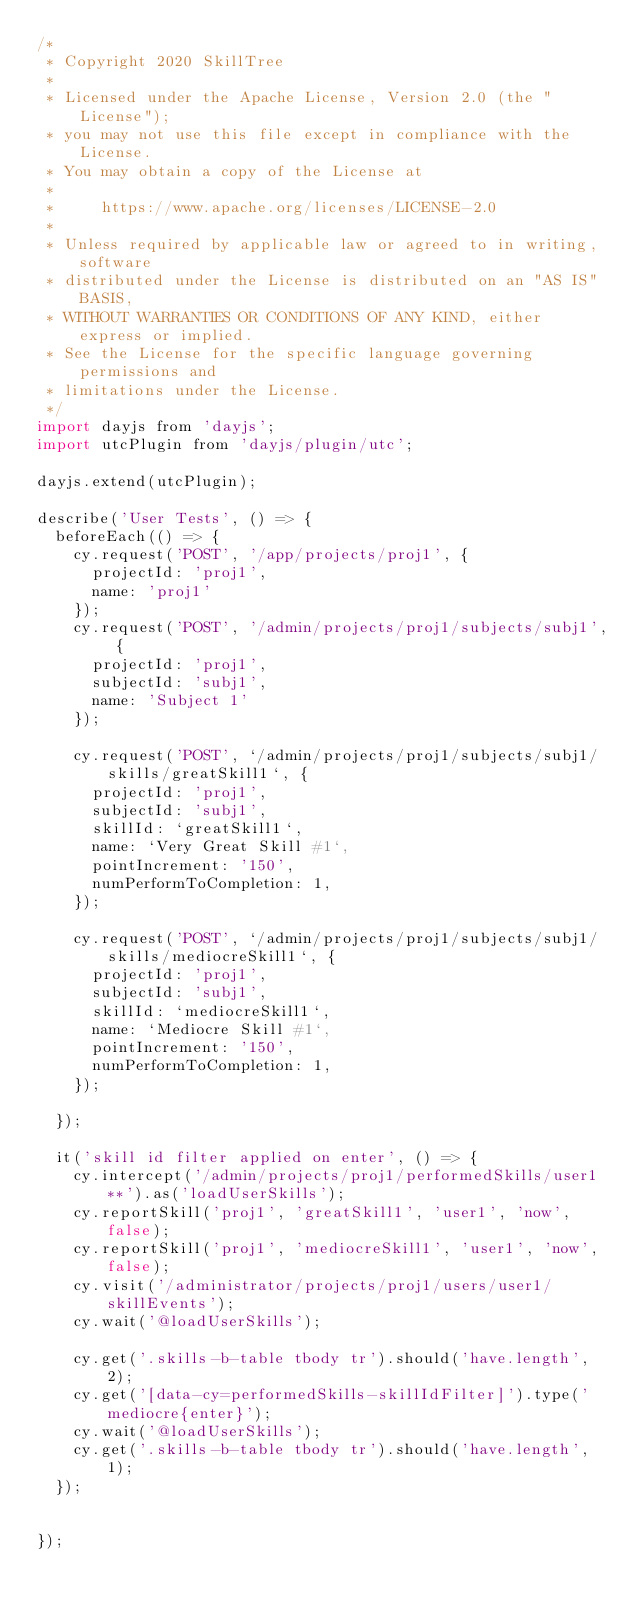Convert code to text. <code><loc_0><loc_0><loc_500><loc_500><_JavaScript_>/*
 * Copyright 2020 SkillTree
 *
 * Licensed under the Apache License, Version 2.0 (the "License");
 * you may not use this file except in compliance with the License.
 * You may obtain a copy of the License at
 *
 *     https://www.apache.org/licenses/LICENSE-2.0
 *
 * Unless required by applicable law or agreed to in writing, software
 * distributed under the License is distributed on an "AS IS" BASIS,
 * WITHOUT WARRANTIES OR CONDITIONS OF ANY KIND, either express or implied.
 * See the License for the specific language governing permissions and
 * limitations under the License.
 */
import dayjs from 'dayjs';
import utcPlugin from 'dayjs/plugin/utc';

dayjs.extend(utcPlugin);

describe('User Tests', () => {
  beforeEach(() => {
    cy.request('POST', '/app/projects/proj1', {
      projectId: 'proj1',
      name: 'proj1'
    });
    cy.request('POST', '/admin/projects/proj1/subjects/subj1', {
      projectId: 'proj1',
      subjectId: 'subj1',
      name: 'Subject 1'
    });

    cy.request('POST', `/admin/projects/proj1/subjects/subj1/skills/greatSkill1`, {
      projectId: 'proj1',
      subjectId: 'subj1',
      skillId: `greatSkill1`,
      name: `Very Great Skill #1`,
      pointIncrement: '150',
      numPerformToCompletion: 1,
    });

    cy.request('POST', `/admin/projects/proj1/subjects/subj1/skills/mediocreSkill1`, {
      projectId: 'proj1',
      subjectId: 'subj1',
      skillId: `mediocreSkill1`,
      name: `Mediocre Skill #1`,
      pointIncrement: '150',
      numPerformToCompletion: 1,
    });

  });

  it('skill id filter applied on enter', () => {
    cy.intercept('/admin/projects/proj1/performedSkills/user1**').as('loadUserSkills');
    cy.reportSkill('proj1', 'greatSkill1', 'user1', 'now', false);
    cy.reportSkill('proj1', 'mediocreSkill1', 'user1', 'now', false);
    cy.visit('/administrator/projects/proj1/users/user1/skillEvents');
    cy.wait('@loadUserSkills');

    cy.get('.skills-b-table tbody tr').should('have.length', 2);
    cy.get('[data-cy=performedSkills-skillIdFilter]').type('mediocre{enter}');
    cy.wait('@loadUserSkills');
    cy.get('.skills-b-table tbody tr').should('have.length', 1);
  });


});
</code> 